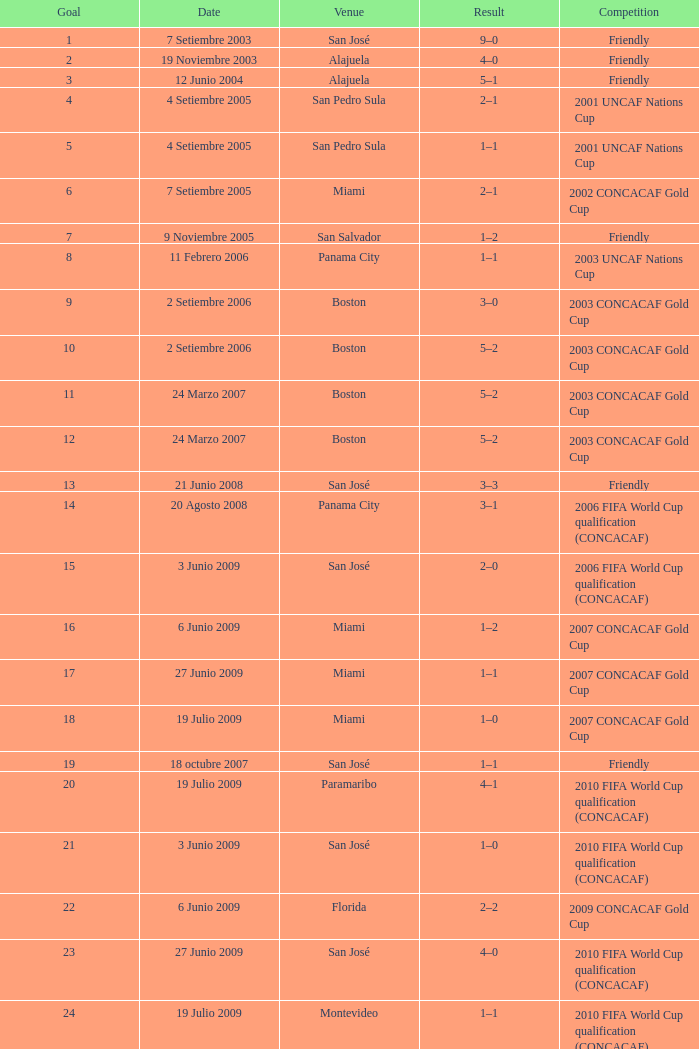Can you parse all the data within this table? {'header': ['Goal', 'Date', 'Venue', 'Result', 'Competition'], 'rows': [['1', '7 Setiembre 2003', 'San José', '9–0', 'Friendly'], ['2', '19 Noviembre 2003', 'Alajuela', '4–0', 'Friendly'], ['3', '12 Junio 2004', 'Alajuela', '5–1', 'Friendly'], ['4', '4 Setiembre 2005', 'San Pedro Sula', '2–1', '2001 UNCAF Nations Cup'], ['5', '4 Setiembre 2005', 'San Pedro Sula', '1–1', '2001 UNCAF Nations Cup'], ['6', '7 Setiembre 2005', 'Miami', '2–1', '2002 CONCACAF Gold Cup'], ['7', '9 Noviembre 2005', 'San Salvador', '1–2', 'Friendly'], ['8', '11 Febrero 2006', 'Panama City', '1–1', '2003 UNCAF Nations Cup'], ['9', '2 Setiembre 2006', 'Boston', '3–0', '2003 CONCACAF Gold Cup'], ['10', '2 Setiembre 2006', 'Boston', '5–2', '2003 CONCACAF Gold Cup'], ['11', '24 Marzo 2007', 'Boston', '5–2', '2003 CONCACAF Gold Cup'], ['12', '24 Marzo 2007', 'Boston', '5–2', '2003 CONCACAF Gold Cup'], ['13', '21 Junio 2008', 'San José', '3–3', 'Friendly'], ['14', '20 Agosto 2008', 'Panama City', '3–1', '2006 FIFA World Cup qualification (CONCACAF)'], ['15', '3 Junio 2009', 'San José', '2–0', '2006 FIFA World Cup qualification (CONCACAF)'], ['16', '6 Junio 2009', 'Miami', '1–2', '2007 CONCACAF Gold Cup'], ['17', '27 Junio 2009', 'Miami', '1–1', '2007 CONCACAF Gold Cup'], ['18', '19 Julio 2009', 'Miami', '1–0', '2007 CONCACAF Gold Cup'], ['19', '18 octubre 2007', 'San José', '1–1', 'Friendly'], ['20', '19 Julio 2009', 'Paramaribo', '4–1', '2010 FIFA World Cup qualification (CONCACAF)'], ['21', '3 Junio 2009', 'San José', '1–0', '2010 FIFA World Cup qualification (CONCACAF)'], ['22', '6 Junio 2009', 'Florida', '2–2', '2009 CONCACAF Gold Cup'], ['23', '27 Junio 2009', 'San José', '4–0', '2010 FIFA World Cup qualification (CONCACAF)'], ['24', '19 Julio 2009', 'Montevideo', '1–1', '2010 FIFA World Cup qualification (CONCACAF)']]} How many goals were netted on 21 june 2008? 1.0. 